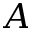Convert formula to latex. <formula><loc_0><loc_0><loc_500><loc_500>A</formula> 